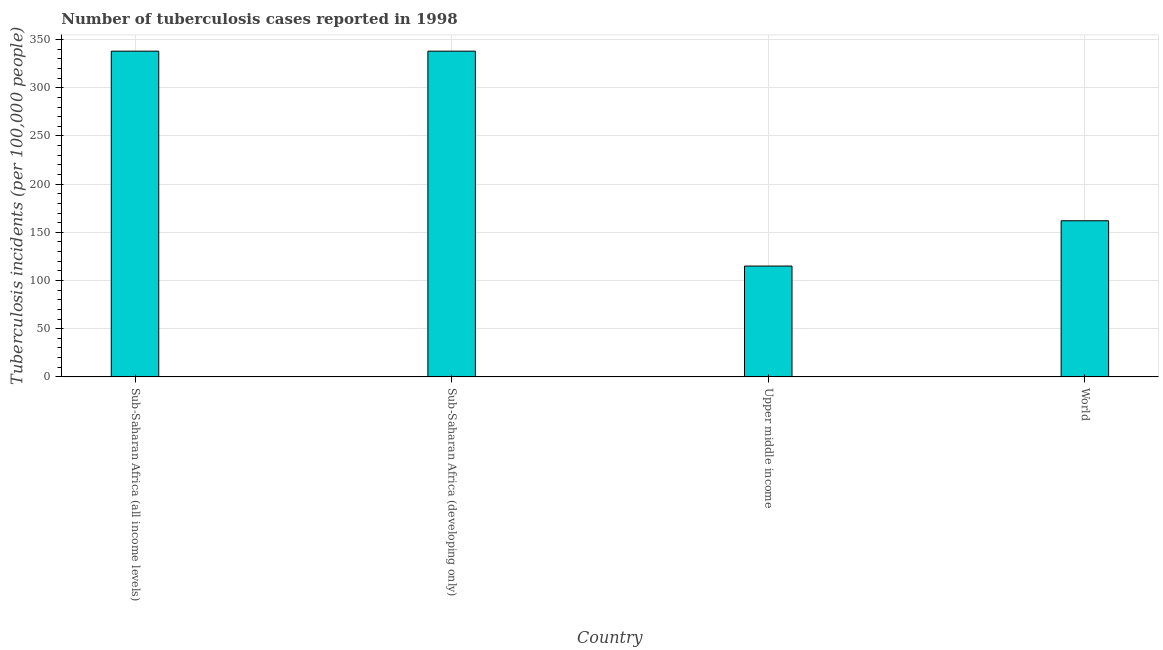What is the title of the graph?
Your answer should be compact. Number of tuberculosis cases reported in 1998. What is the label or title of the Y-axis?
Provide a succinct answer. Tuberculosis incidents (per 100,0 people). What is the number of tuberculosis incidents in Sub-Saharan Africa (all income levels)?
Ensure brevity in your answer.  338. Across all countries, what is the maximum number of tuberculosis incidents?
Give a very brief answer. 338. Across all countries, what is the minimum number of tuberculosis incidents?
Your answer should be compact. 115. In which country was the number of tuberculosis incidents maximum?
Give a very brief answer. Sub-Saharan Africa (all income levels). In which country was the number of tuberculosis incidents minimum?
Make the answer very short. Upper middle income. What is the sum of the number of tuberculosis incidents?
Your response must be concise. 953. What is the difference between the number of tuberculosis incidents in Sub-Saharan Africa (all income levels) and World?
Provide a succinct answer. 176. What is the average number of tuberculosis incidents per country?
Ensure brevity in your answer.  238.25. What is the median number of tuberculosis incidents?
Your answer should be very brief. 250. What is the ratio of the number of tuberculosis incidents in Sub-Saharan Africa (developing only) to that in Upper middle income?
Your answer should be compact. 2.94. What is the difference between the highest and the second highest number of tuberculosis incidents?
Your answer should be compact. 0. Is the sum of the number of tuberculosis incidents in Sub-Saharan Africa (all income levels) and Sub-Saharan Africa (developing only) greater than the maximum number of tuberculosis incidents across all countries?
Provide a succinct answer. Yes. What is the difference between the highest and the lowest number of tuberculosis incidents?
Provide a succinct answer. 223. In how many countries, is the number of tuberculosis incidents greater than the average number of tuberculosis incidents taken over all countries?
Provide a short and direct response. 2. Are the values on the major ticks of Y-axis written in scientific E-notation?
Your answer should be compact. No. What is the Tuberculosis incidents (per 100,000 people) in Sub-Saharan Africa (all income levels)?
Offer a terse response. 338. What is the Tuberculosis incidents (per 100,000 people) in Sub-Saharan Africa (developing only)?
Make the answer very short. 338. What is the Tuberculosis incidents (per 100,000 people) in Upper middle income?
Provide a short and direct response. 115. What is the Tuberculosis incidents (per 100,000 people) in World?
Provide a short and direct response. 162. What is the difference between the Tuberculosis incidents (per 100,000 people) in Sub-Saharan Africa (all income levels) and Upper middle income?
Offer a very short reply. 223. What is the difference between the Tuberculosis incidents (per 100,000 people) in Sub-Saharan Africa (all income levels) and World?
Offer a terse response. 176. What is the difference between the Tuberculosis incidents (per 100,000 people) in Sub-Saharan Africa (developing only) and Upper middle income?
Offer a very short reply. 223. What is the difference between the Tuberculosis incidents (per 100,000 people) in Sub-Saharan Africa (developing only) and World?
Your response must be concise. 176. What is the difference between the Tuberculosis incidents (per 100,000 people) in Upper middle income and World?
Provide a succinct answer. -47. What is the ratio of the Tuberculosis incidents (per 100,000 people) in Sub-Saharan Africa (all income levels) to that in Sub-Saharan Africa (developing only)?
Keep it short and to the point. 1. What is the ratio of the Tuberculosis incidents (per 100,000 people) in Sub-Saharan Africa (all income levels) to that in Upper middle income?
Keep it short and to the point. 2.94. What is the ratio of the Tuberculosis incidents (per 100,000 people) in Sub-Saharan Africa (all income levels) to that in World?
Ensure brevity in your answer.  2.09. What is the ratio of the Tuberculosis incidents (per 100,000 people) in Sub-Saharan Africa (developing only) to that in Upper middle income?
Your answer should be compact. 2.94. What is the ratio of the Tuberculosis incidents (per 100,000 people) in Sub-Saharan Africa (developing only) to that in World?
Make the answer very short. 2.09. What is the ratio of the Tuberculosis incidents (per 100,000 people) in Upper middle income to that in World?
Make the answer very short. 0.71. 